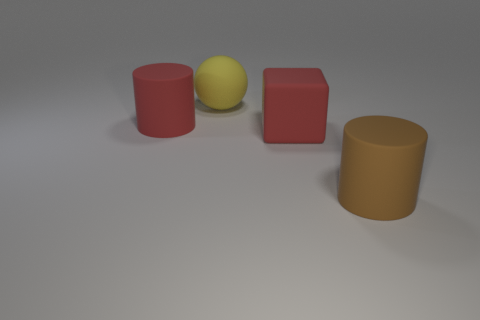Add 2 brown things. How many objects exist? 6 Subtract all blocks. How many objects are left? 3 Subtract 1 brown cylinders. How many objects are left? 3 Subtract all cyan cylinders. Subtract all brown cylinders. How many objects are left? 3 Add 1 rubber cubes. How many rubber cubes are left? 2 Add 2 large brown metal objects. How many large brown metal objects exist? 2 